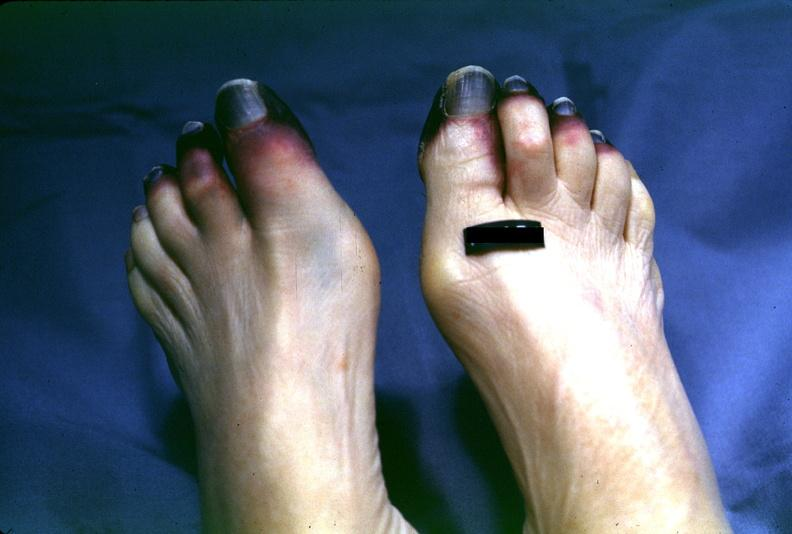re extremities present?
Answer the question using a single word or phrase. Yes 